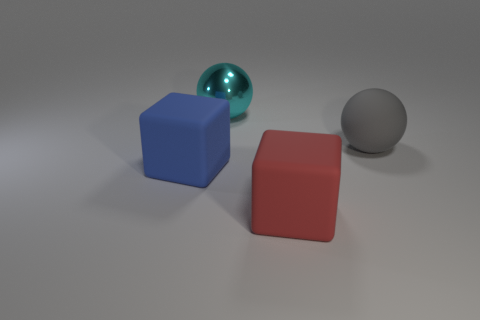Add 3 gray matte balls. How many objects exist? 7 Add 3 metallic spheres. How many metallic spheres exist? 4 Subtract 1 blue blocks. How many objects are left? 3 Subtract all big red objects. Subtract all shiny things. How many objects are left? 2 Add 3 big gray rubber balls. How many big gray rubber balls are left? 4 